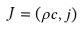Convert formula to latex. <formula><loc_0><loc_0><loc_500><loc_500>J = ( \rho c , j )</formula> 